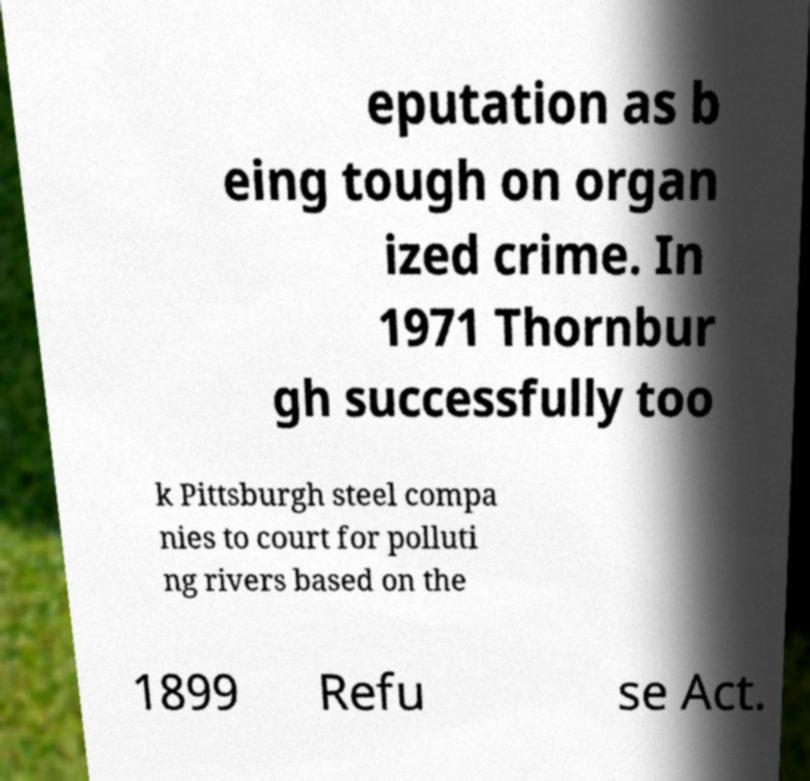Can you accurately transcribe the text from the provided image for me? eputation as b eing tough on organ ized crime. In 1971 Thornbur gh successfully too k Pittsburgh steel compa nies to court for polluti ng rivers based on the 1899 Refu se Act. 